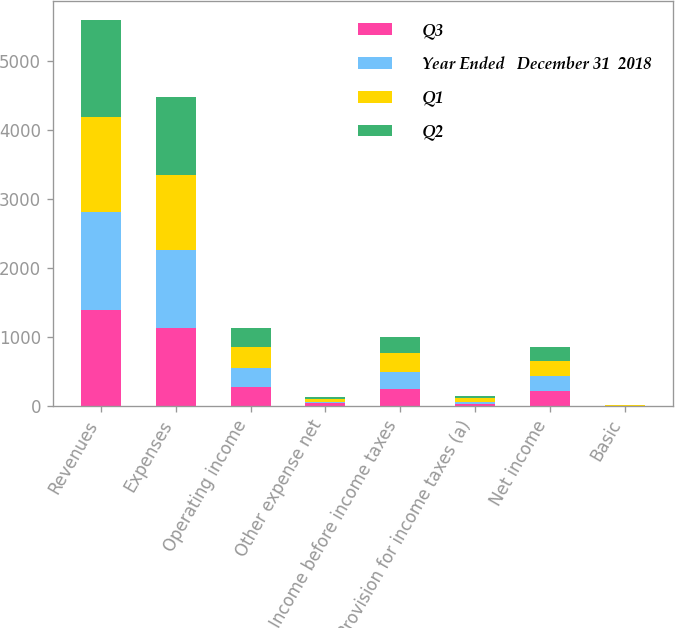Convert chart to OTSL. <chart><loc_0><loc_0><loc_500><loc_500><stacked_bar_chart><ecel><fcel>Revenues<fcel>Expenses<fcel>Operating income<fcel>Other expense net<fcel>Income before income taxes<fcel>Provision for income taxes (a)<fcel>Net income<fcel>Basic<nl><fcel>Q3<fcel>1389.4<fcel>1124.5<fcel>264.9<fcel>30.4<fcel>234.5<fcel>20.9<fcel>213.6<fcel>0.46<nl><fcel>Year Ended   December 31  2018<fcel>1411.1<fcel>1127.5<fcel>283.6<fcel>28.1<fcel>255.5<fcel>37.9<fcel>217.6<fcel>0.48<nl><fcel>Q1<fcel>1387.8<fcel>1085.2<fcel>302.6<fcel>36.2<fcel>266.4<fcel>57.8<fcel>208.6<fcel>0.47<nl><fcel>Q2<fcel>1401.6<fcel>1130.6<fcel>271<fcel>36<fcel>235<fcel>22.9<fcel>212.1<fcel>0.48<nl></chart> 